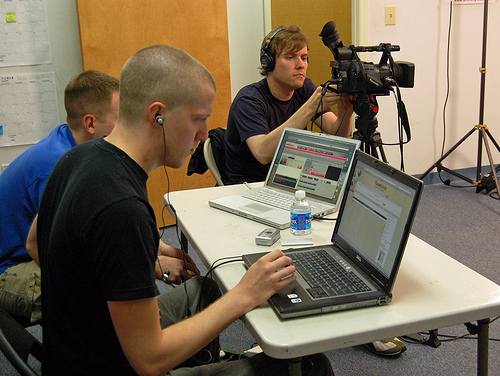<image>What color is the sock of the men? I don't know the color of the men's sock. It is possibly white or there might not be any socks visible. What branch of the military is the man from? It is unknown what branch of the military the man is from. It could be army or marine, or he may not be in the military at all. What color is the sock of the men? The color of the men's sock is white. What branch of the military is the man from? I don't know what branch of the military the man is from. It can be army or marine. 